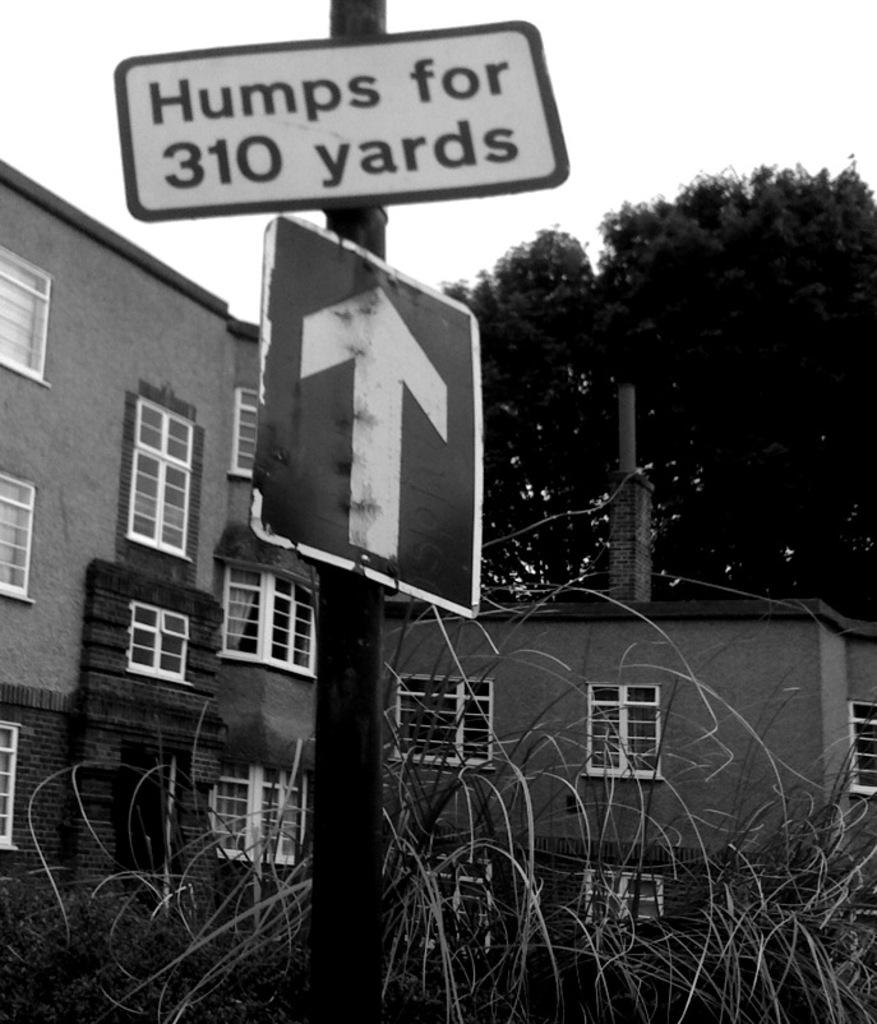What type of structures are visible in the image? There are buildings with windows in the image. What other elements can be seen in the image besides buildings? There are trees and signboards visible in the image. What is visible in the background of the image? The sky is visible in the background of the image. What news is being broadcasted on the gold holiday signboard in the image? There is no news, gold, or holiday signboard present in the image. 